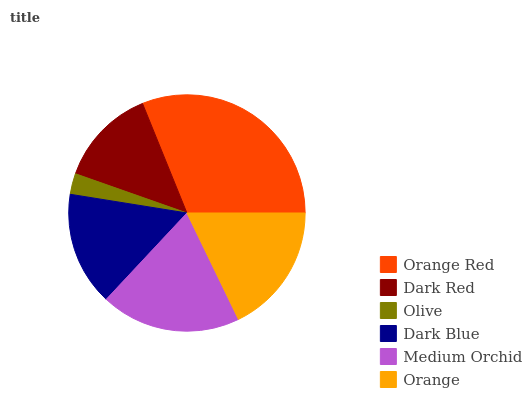Is Olive the minimum?
Answer yes or no. Yes. Is Orange Red the maximum?
Answer yes or no. Yes. Is Dark Red the minimum?
Answer yes or no. No. Is Dark Red the maximum?
Answer yes or no. No. Is Orange Red greater than Dark Red?
Answer yes or no. Yes. Is Dark Red less than Orange Red?
Answer yes or no. Yes. Is Dark Red greater than Orange Red?
Answer yes or no. No. Is Orange Red less than Dark Red?
Answer yes or no. No. Is Orange the high median?
Answer yes or no. Yes. Is Dark Blue the low median?
Answer yes or no. Yes. Is Medium Orchid the high median?
Answer yes or no. No. Is Orange Red the low median?
Answer yes or no. No. 